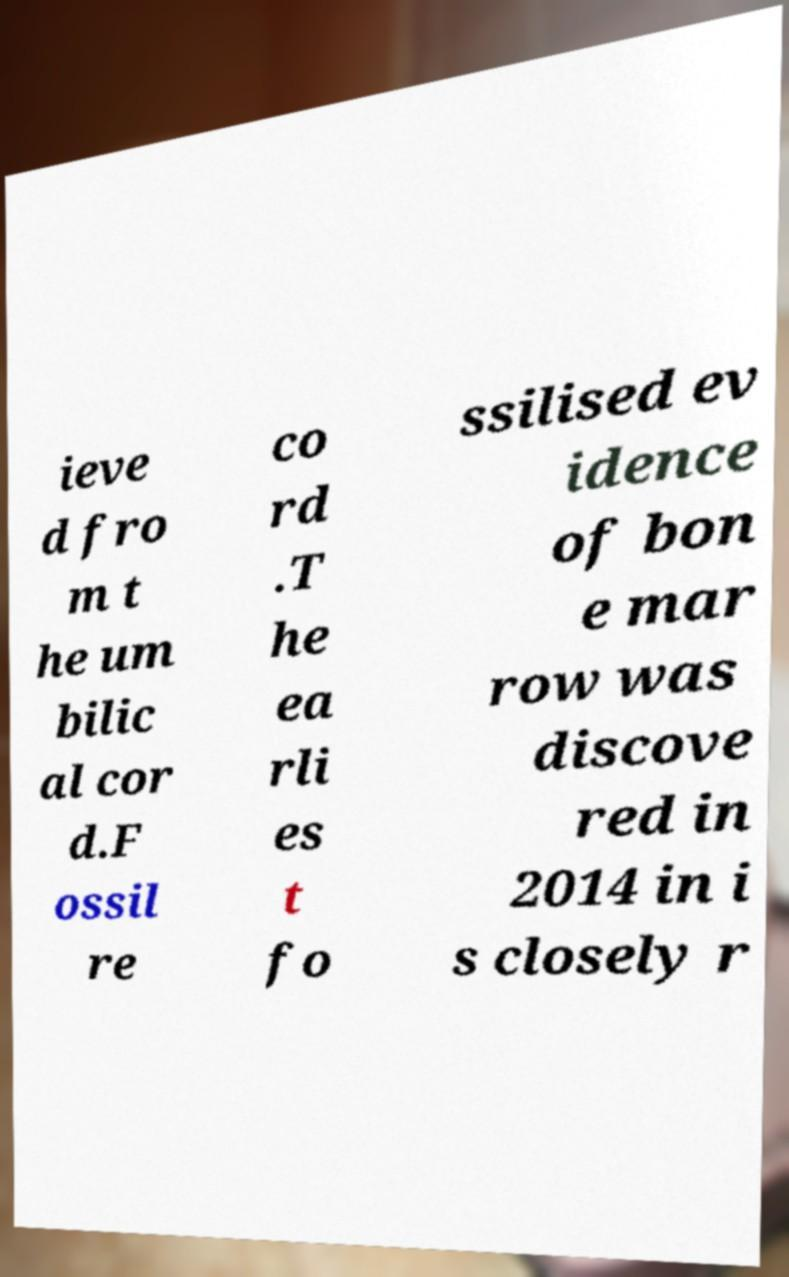Could you extract and type out the text from this image? ieve d fro m t he um bilic al cor d.F ossil re co rd .T he ea rli es t fo ssilised ev idence of bon e mar row was discove red in 2014 in i s closely r 